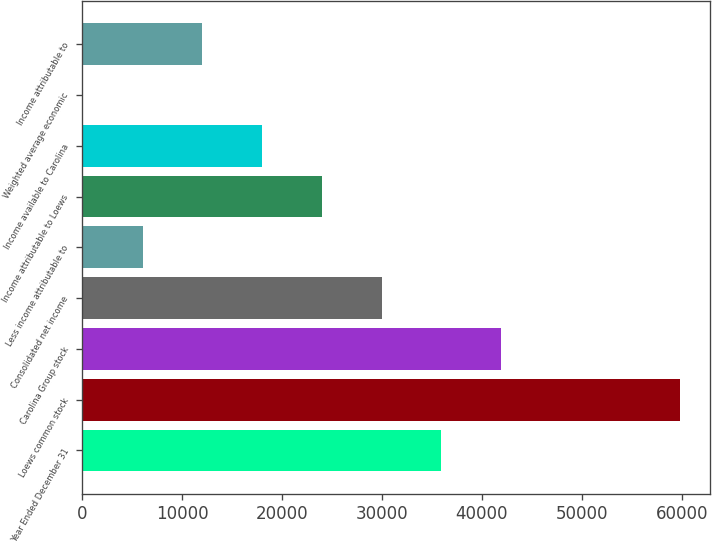Convert chart. <chart><loc_0><loc_0><loc_500><loc_500><bar_chart><fcel>Year Ended December 31<fcel>Loews common stock<fcel>Carolina Group stock<fcel>Consolidated net income<fcel>Less income attributable to<fcel>Income attributable to Loews<fcel>Income available to Carolina<fcel>Weighted average economic<fcel>Income attributable to<nl><fcel>35933.3<fcel>59862<fcel>41915.5<fcel>29951.2<fcel>6022.47<fcel>23969<fcel>17986.8<fcel>40.3<fcel>12004.6<nl></chart> 